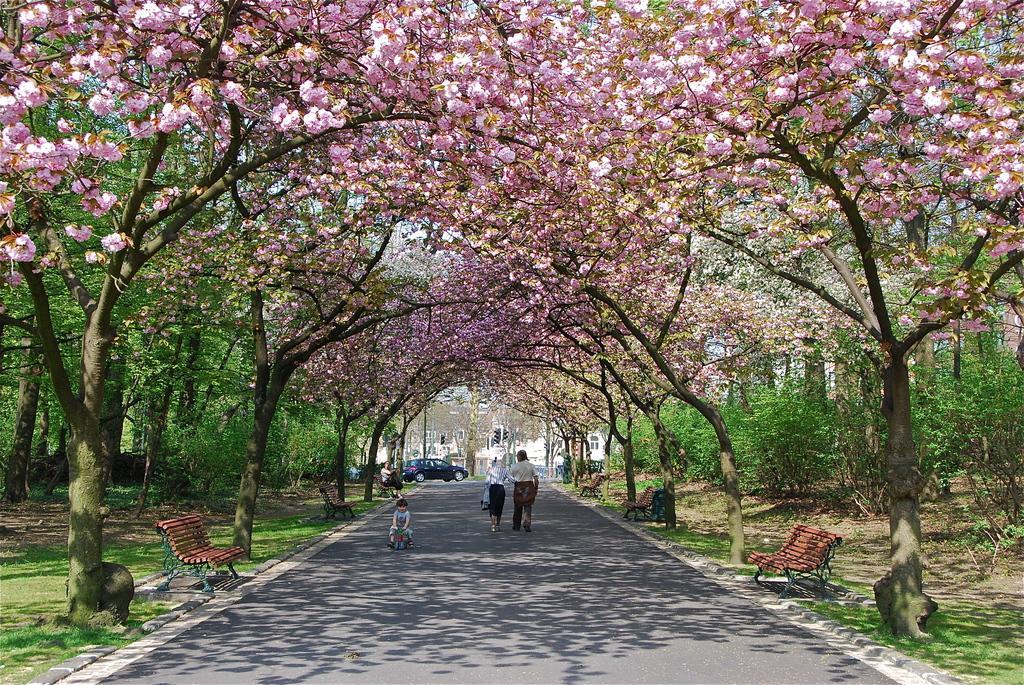Describe this image in one or two sentences. In this image there are two people walking on the road and a child is riding a bicycle, there is a person sitting on the bench and there is a vehicle. On the left and right side of the image there are trees and benches. In the background there are buildings. 